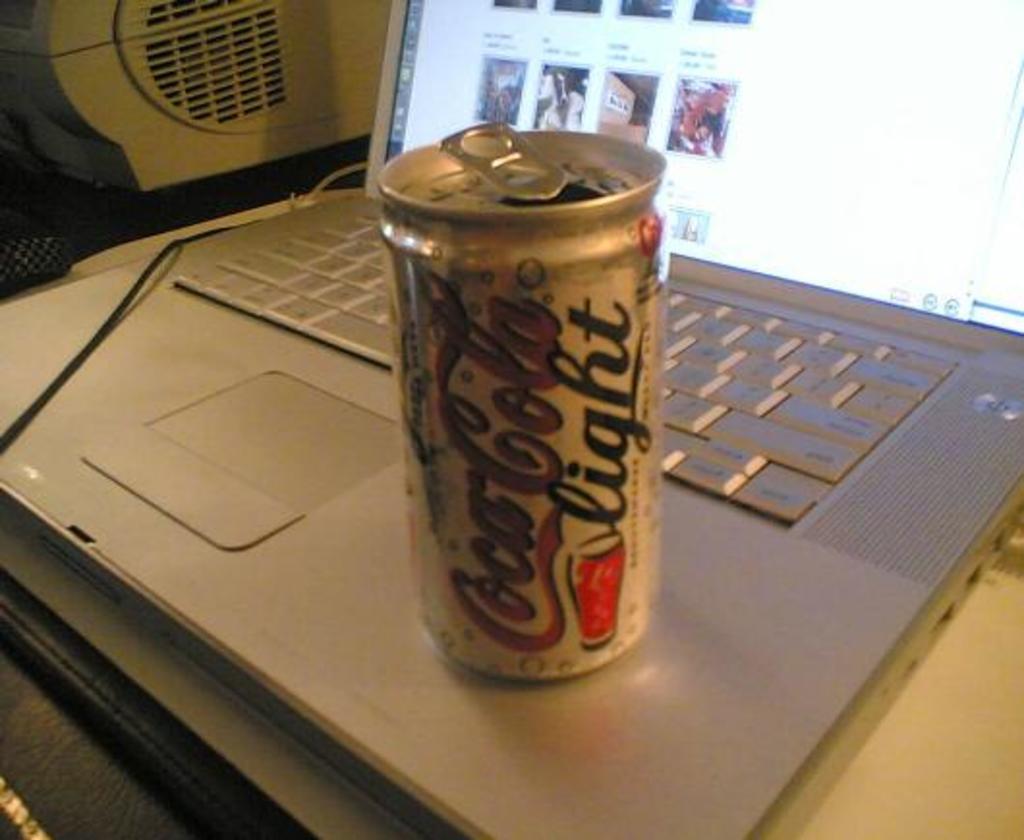What kind of coca cola is this?
Offer a very short reply. Light. 